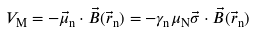Convert formula to latex. <formula><loc_0><loc_0><loc_500><loc_500>V _ { \mathrm M } = - \vec { \mu } _ { \mathrm n } \cdot \vec { B } ( \vec { r } _ { \mathrm n } ) = - \gamma _ { \mathrm n } \mu _ { \mathrm N } \vec { \sigma } \cdot \vec { B } ( \vec { r } _ { \mathrm n } )</formula> 